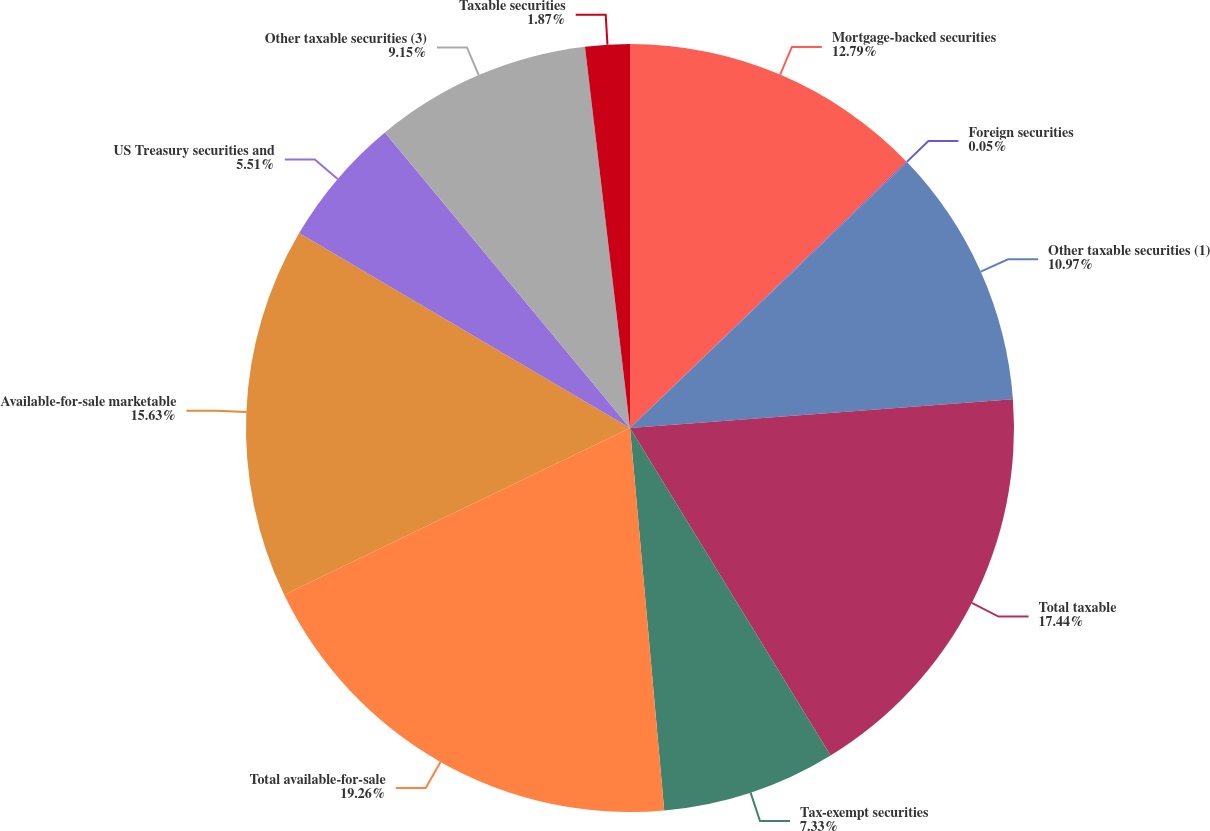Convert chart. <chart><loc_0><loc_0><loc_500><loc_500><pie_chart><fcel>Mortgage-backed securities<fcel>Foreign securities<fcel>Other taxable securities (1)<fcel>Total taxable<fcel>Tax-exempt securities<fcel>Total available-for-sale<fcel>Available-for-sale marketable<fcel>US Treasury securities and<fcel>Other taxable securities (3)<fcel>Taxable securities<nl><fcel>12.79%<fcel>0.05%<fcel>10.97%<fcel>17.45%<fcel>7.33%<fcel>19.27%<fcel>15.63%<fcel>5.51%<fcel>9.15%<fcel>1.87%<nl></chart> 